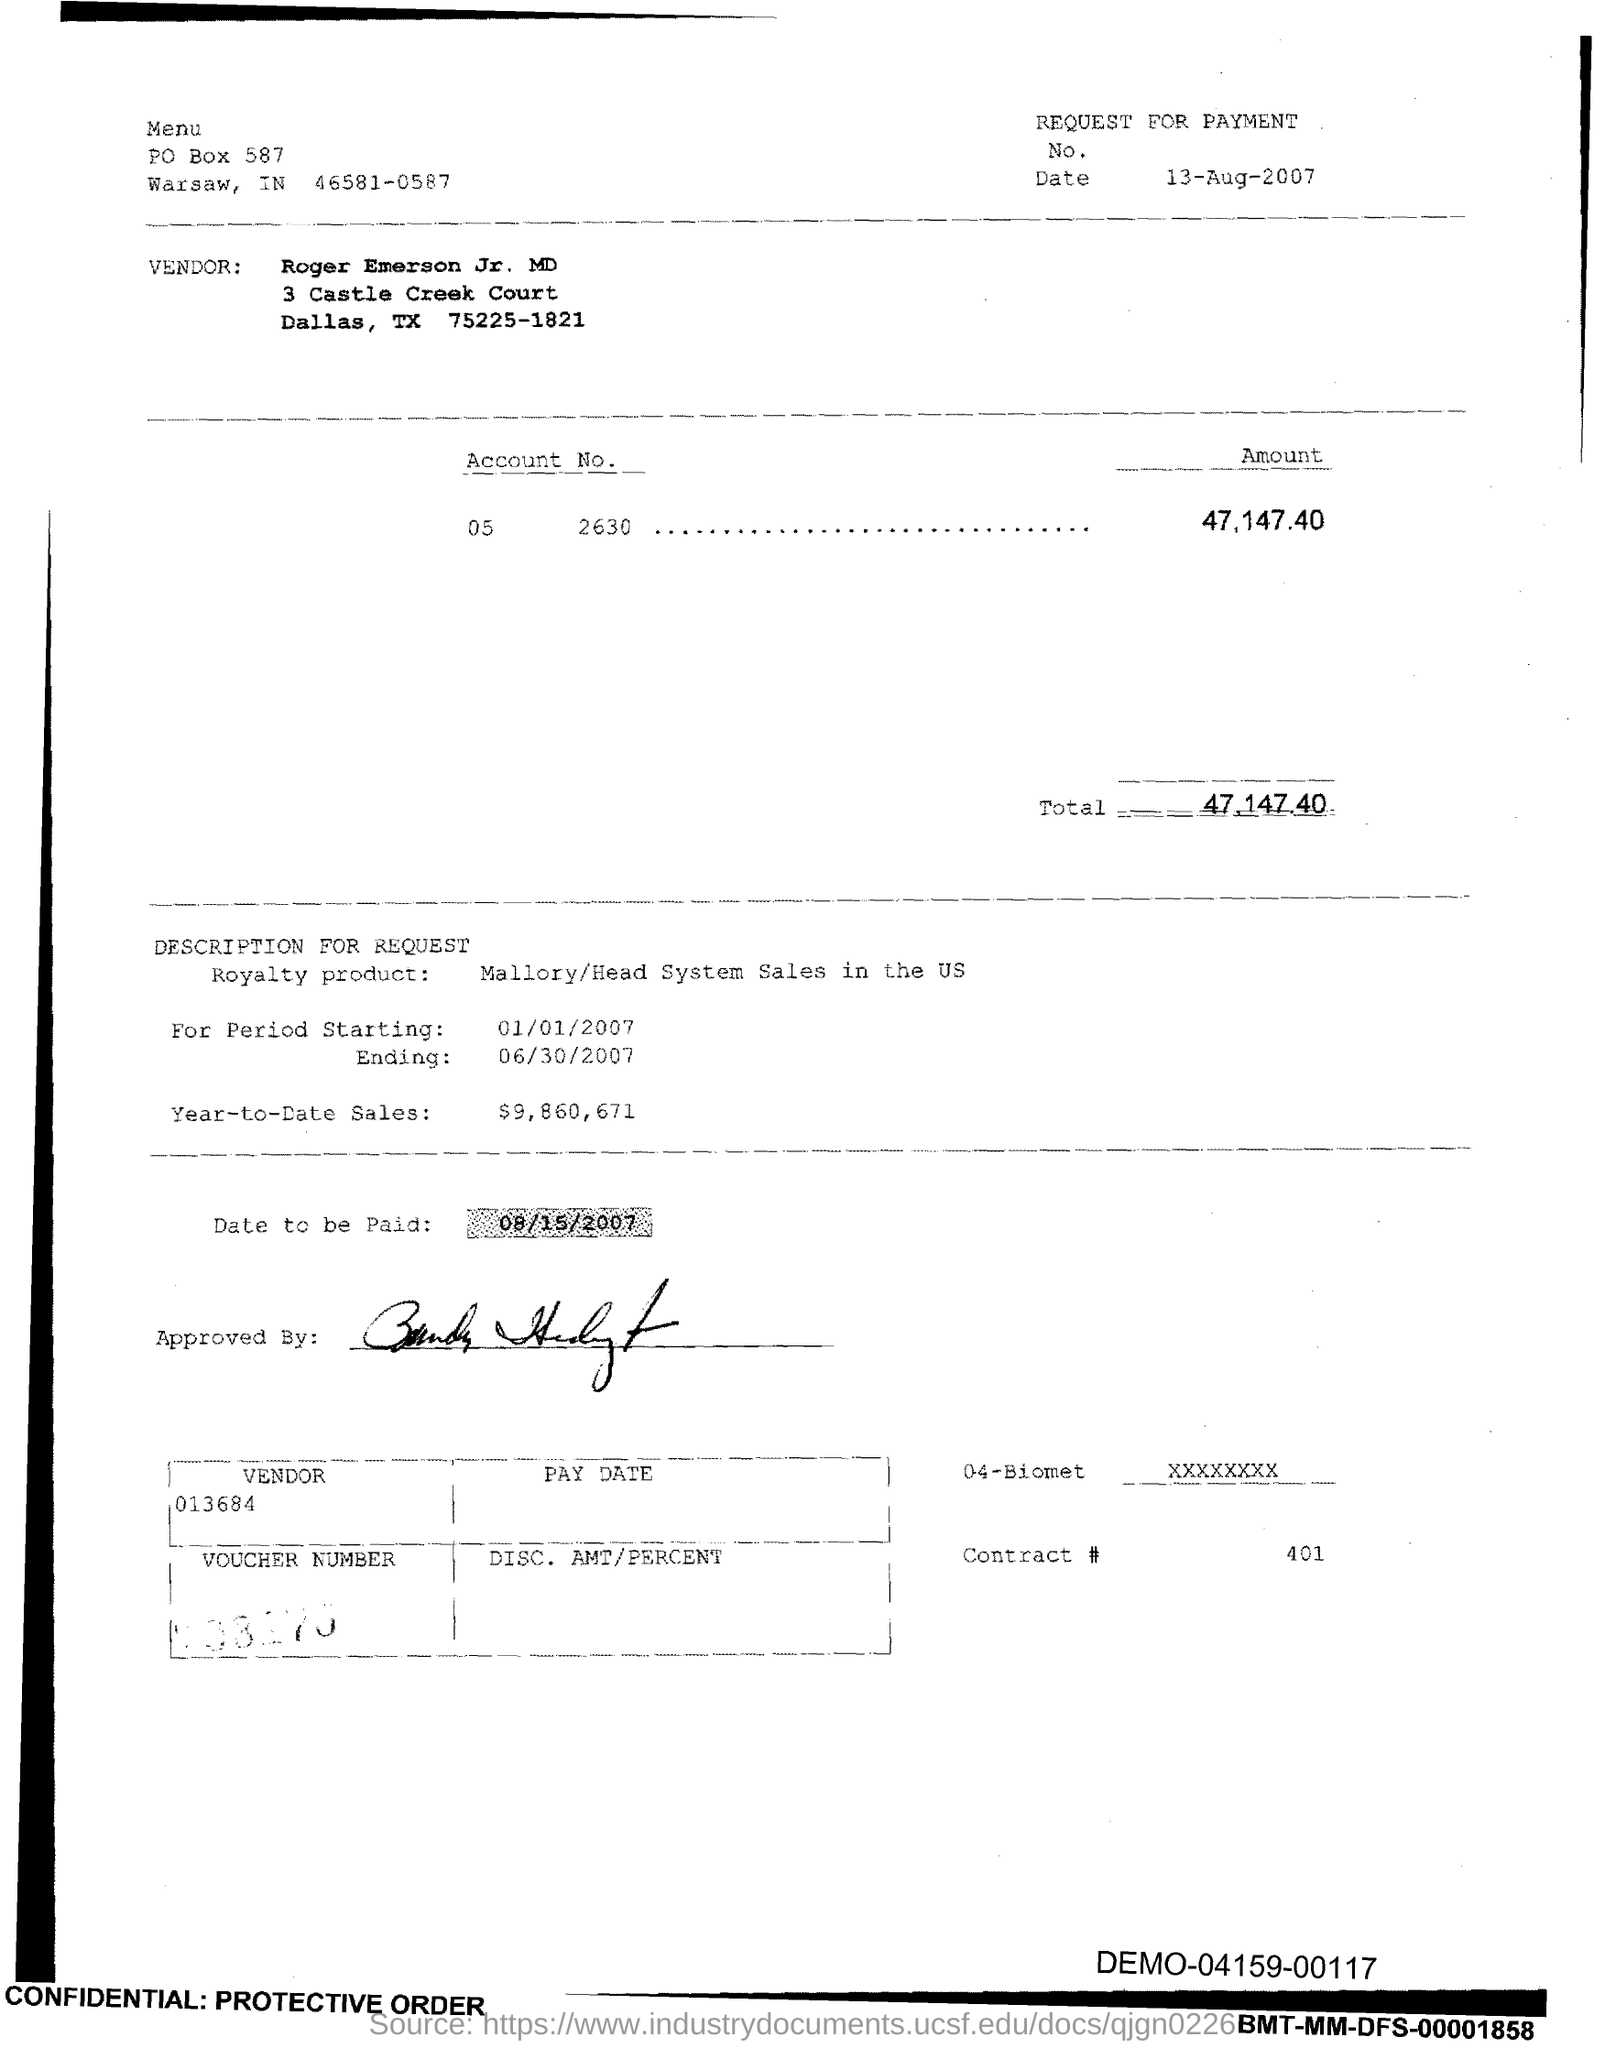What is the Contract # Number?
Provide a short and direct response. 401. What is the Total?
Give a very brief answer. 47,147.40. What is the Year-to-Date-Sales?
Offer a terse response. $9,860,671. 